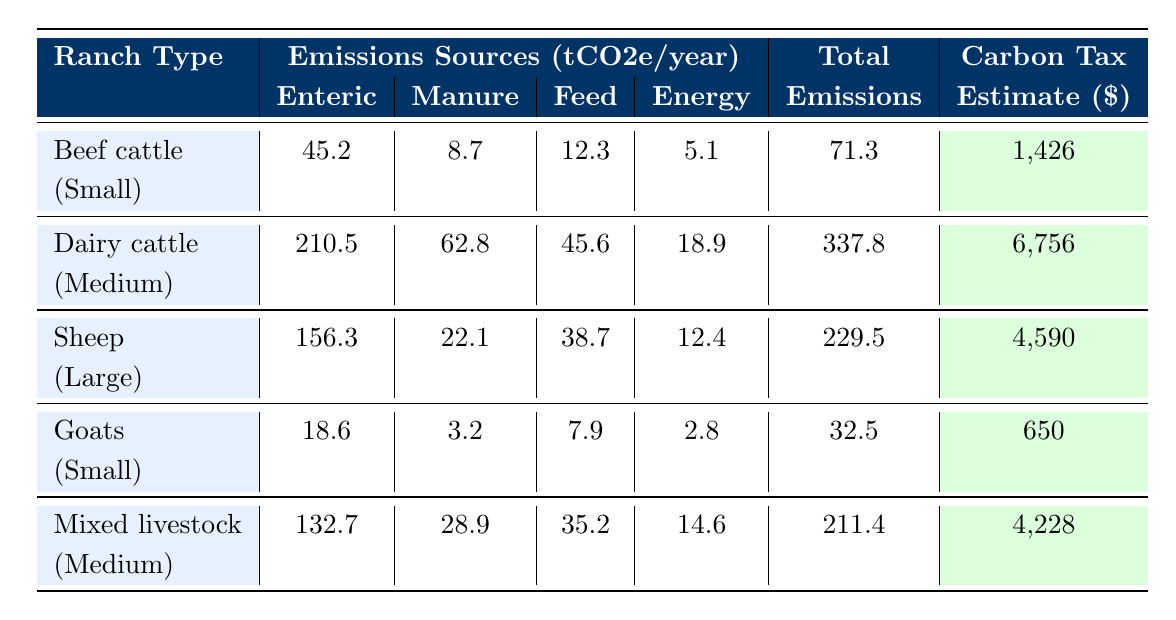What ranch type has the highest carbon tax estimate? Looking at the "Carbon Tax Estimate" column, the figures for each ranch type are: Beef cattle - $1,426, Dairy cattle - $6,756, Sheep - $4,590, Goats - $650, Mixed livestock - $4,228. Dairy cattle has the highest estimate of $6,756.
Answer: Dairy cattle What is the total emissions for small-sized Goats? From the table, we find that the total emissions for small-sized Goats is 32.5 tCO2e/year, as listed in the "Total" column.
Answer: 32.5 tCO2e/year Which ranch type produces the most emissions from enteric fermentation? By looking at the "Enteric" column, we see the emissions for each ranch type: Beef cattle - 45.2, Dairy cattle - 210.5, Sheep - 156.3, Goats - 18.6, and Mixed livestock - 132.7. Dairy cattle produces the most at 210.5 tCO2e/year.
Answer: Dairy cattle What is the difference in total emissions between Medium Dairy cattle and Medium Mixed livestock? The total emissions for Medium Dairy cattle is 337.8 tCO2e/year and for Medium Mixed livestock it is 211.4 tCO2e/year. The difference would be 337.8 - 211.4 = 126.4 tCO2e/year.
Answer: 126.4 tCO2e/year Do small ranches (under 100 head) produce more or less carbon emissions than large ranches (over 500 head)? For small ranches, the total emissions are 71.3 (Beef cattle) and 32.5 (Goats), which sum to 103.8 tCO2e/year. For large ranches, Sheep emits 229.5 tCO2e/year. Since 103.8 is less than 229.5, small ranches produce less emissions.
Answer: Less What is the average carbon tax estimate for all ranch types listed? The carbon tax estimates are: Beef cattle - 1,426, Dairy cattle - 6,756, Sheep - 4,590, Goats - 650, and Mixed livestock - 4,228. Adding these gives 1,426 + 6,756 + 4,590 + 650 + 4,228 = 17,650. The average is 17,650 / 5 = 3,530.
Answer: 3,530 Which ranch type contributes the least to emissions from feed production? In the "Feed" column, the values are: Beef cattle - 12.3, Dairy cattle - 45.6, Sheep - 38.7, Goats - 7.9, Mixed livestock - 35.2. The smallest value is for Goats at 7.9 tCO2e/year.
Answer: Goats If we combine the emissions from manure management of Sheep and Dairy cattle, what will be the total? The manure management emissions for Sheep is 22.1 and for Dairy cattle is 62.8. Their combined total is 22.1 + 62.8 = 84.9 tCO2e/year.
Answer: 84.9 tCO2e/year 